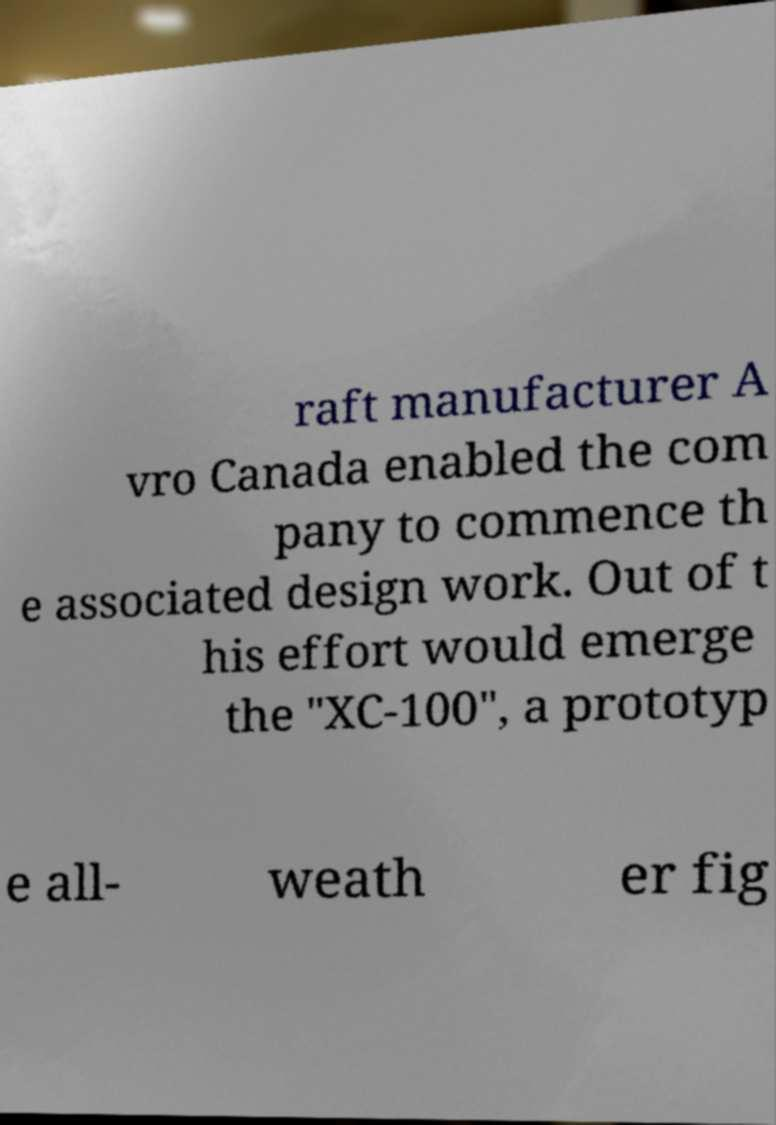Could you assist in decoding the text presented in this image and type it out clearly? raft manufacturer A vro Canada enabled the com pany to commence th e associated design work. Out of t his effort would emerge the "XC-100", a prototyp e all- weath er fig 